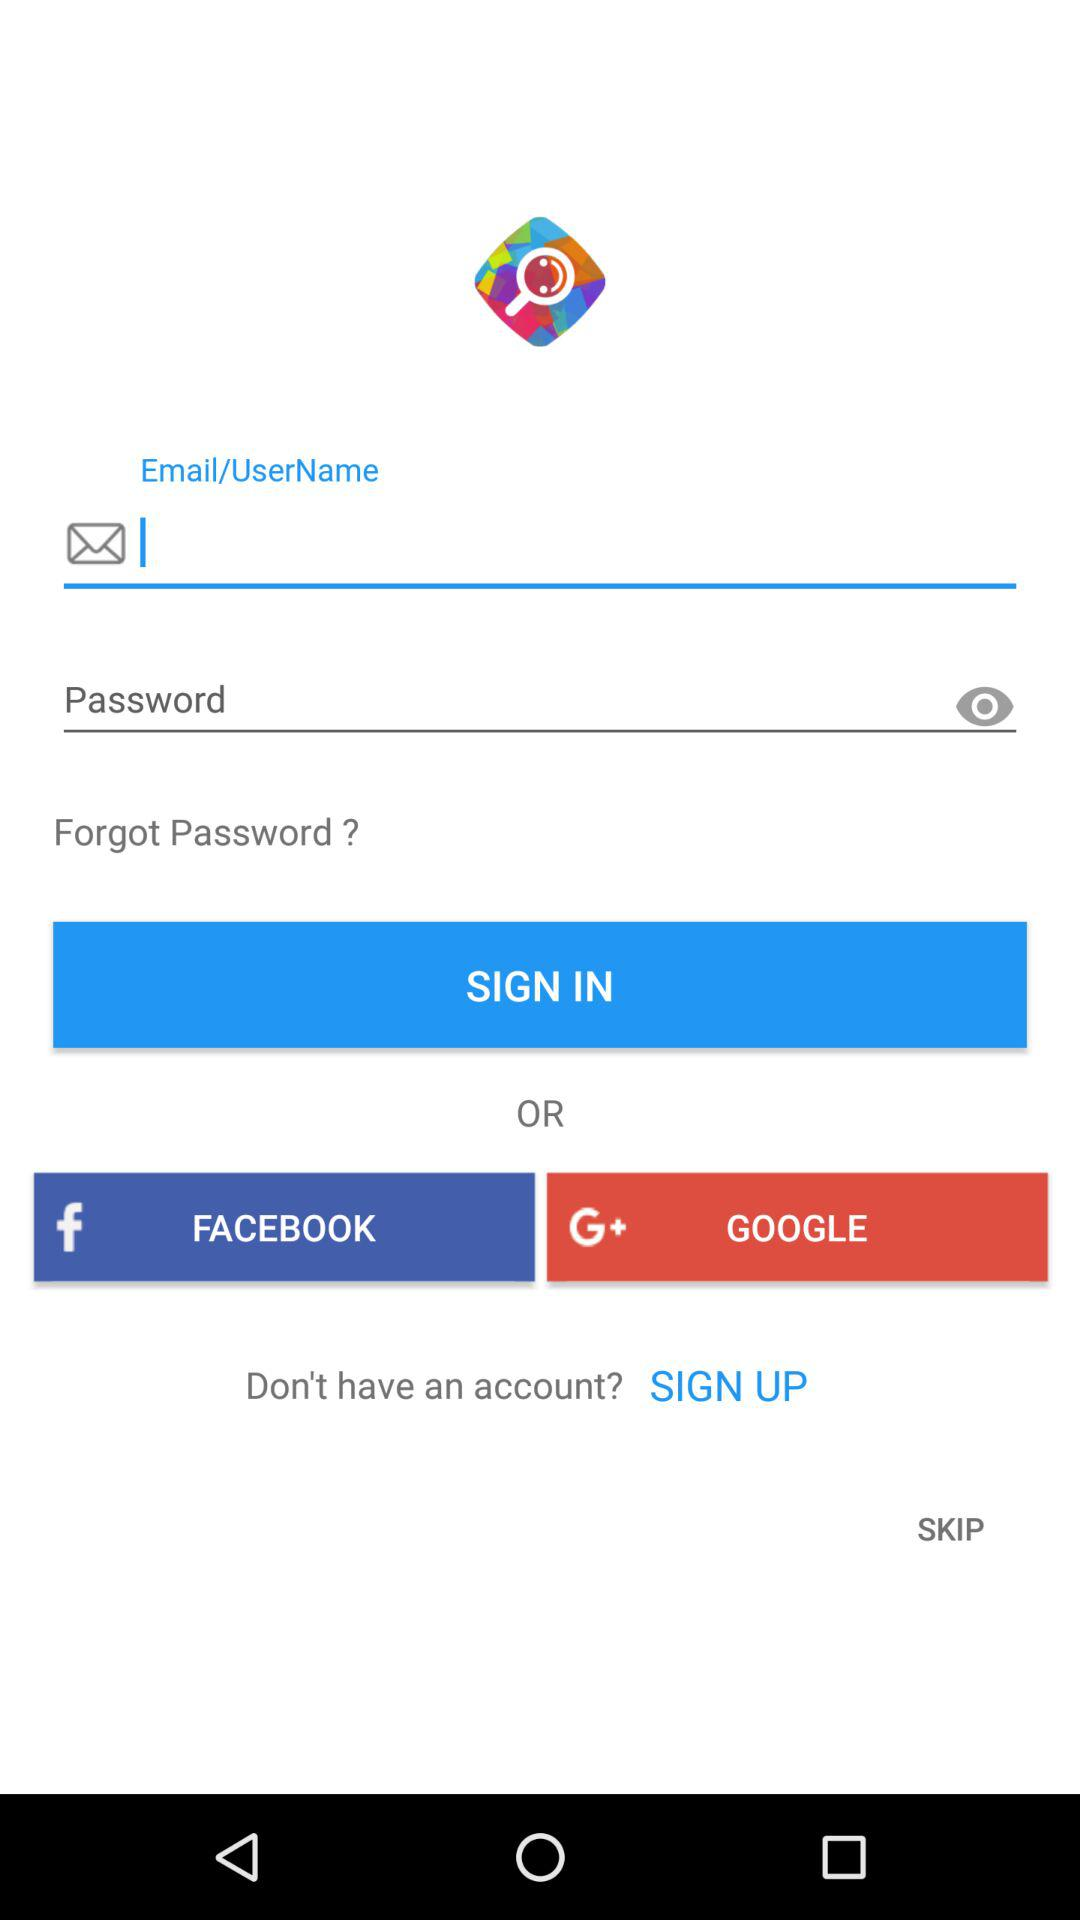Through what different options can we sign in? You can sign in through "FACEBOOK" and "GOOGLE". 